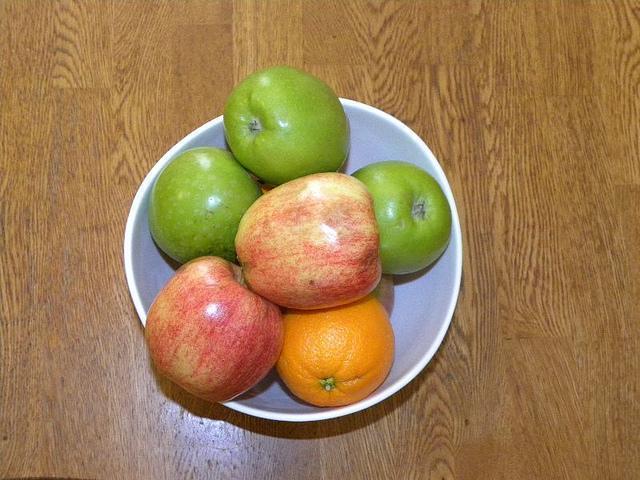How many different kinds of apples are in the bowl?
Give a very brief answer. 2. How many of the apples are peeled?
Give a very brief answer. 0. How many apples are pictured?
Give a very brief answer. 5. How many apples have been cut up?
Give a very brief answer. 0. How many apples are there?
Give a very brief answer. 5. How many bear claws?
Give a very brief answer. 0. 